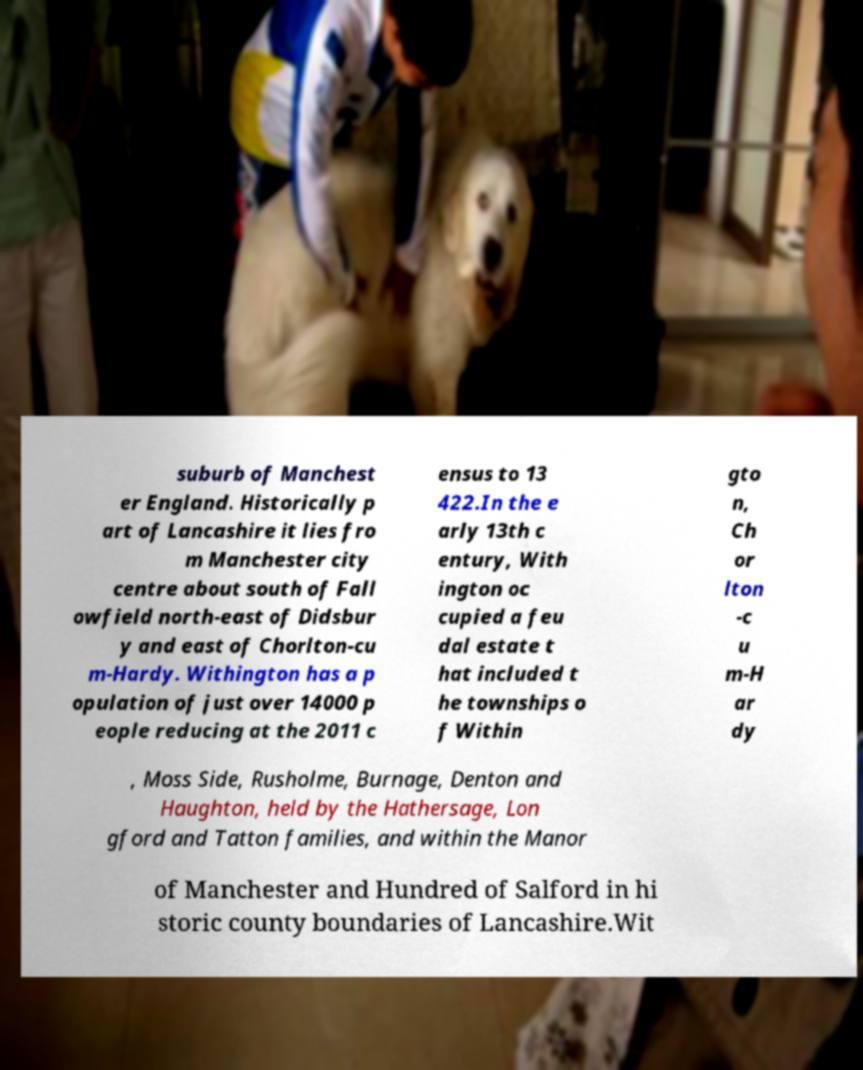Please read and relay the text visible in this image. What does it say? suburb of Manchest er England. Historically p art of Lancashire it lies fro m Manchester city centre about south of Fall owfield north-east of Didsbur y and east of Chorlton-cu m-Hardy. Withington has a p opulation of just over 14000 p eople reducing at the 2011 c ensus to 13 422.In the e arly 13th c entury, With ington oc cupied a feu dal estate t hat included t he townships o f Within gto n, Ch or lton -c u m-H ar dy , Moss Side, Rusholme, Burnage, Denton and Haughton, held by the Hathersage, Lon gford and Tatton families, and within the Manor of Manchester and Hundred of Salford in hi storic county boundaries of Lancashire.Wit 